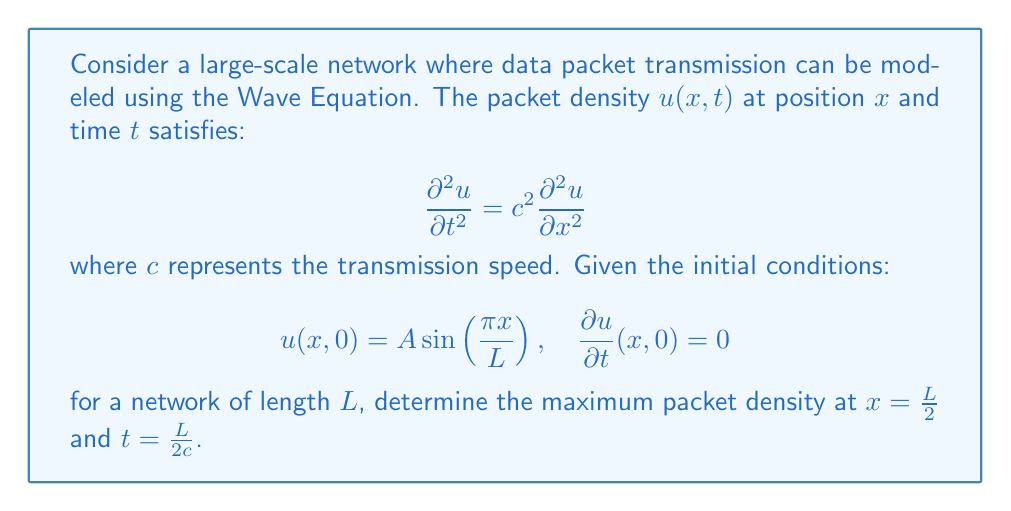Solve this math problem. To solve this problem, we'll follow these steps:

1) The general solution to the Wave Equation with these initial conditions is:

   $$u(x,t) = A\cos(\frac{c\pi t}{L})\sin(\frac{\pi x}{L})$$

2) We need to find the value of $u(x,t)$ at $x = \frac{L}{2}$ and $t = \frac{L}{2c}$:

   $$u(\frac{L}{2},\frac{L}{2c}) = A\cos(\frac{c\pi}{2c})\sin(\frac{\pi L/2}{L})$$

3) Simplify:
   
   $$u(\frac{L}{2},\frac{L}{2c}) = A\cos(\frac{\pi}{2})\sin(\frac{\pi}{2})$$

4) Evaluate:
   
   $$\cos(\frac{\pi}{2}) = 0, \quad \sin(\frac{\pi}{2}) = 1$$

5) Therefore:

   $$u(\frac{L}{2},\frac{L}{2c}) = A \cdot 0 \cdot 1 = 0$$

This means that at $x = \frac{L}{2}$ and $t = \frac{L}{2c}$, the packet density is zero. However, the question asks for the maximum packet density at this position.

6) To find the maximum, we need to consider all possible times. The cosine term in the solution oscillates between -1 and 1, so the maximum occurs when $\cos(\frac{c\pi t}{L}) = \pm 1$.

7) Therefore, the maximum packet density at $x = \frac{L}{2}$ is:

   $$u_{max}(\frac{L}{2},t) = A\sin(\frac{\pi}{2}) = A$$
Answer: $A$ 